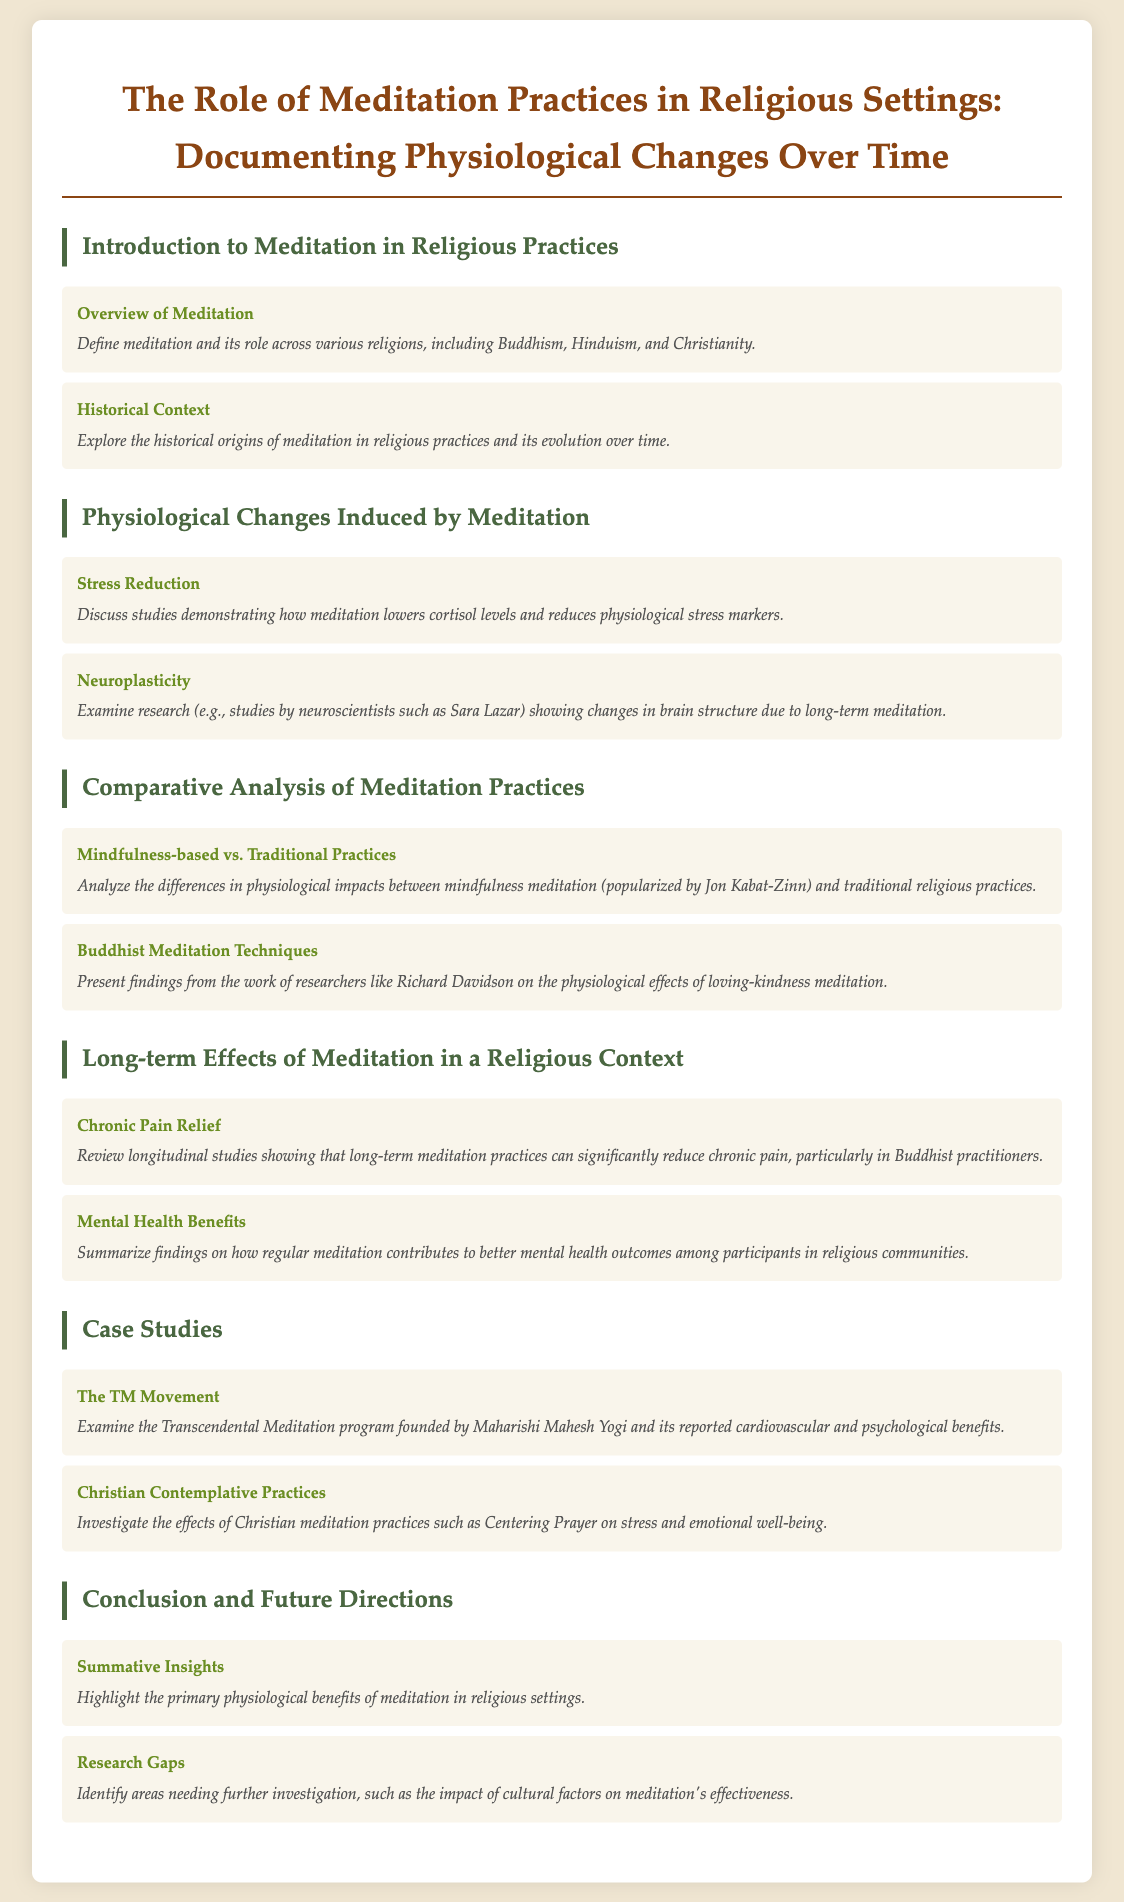What are the two major sections in the document? The document is organized into major sections including "Introduction to Meditation in Religious Practices" and "Physiological Changes Induced by Meditation."
Answer: Introduction to Meditation in Religious Practices and Physiological Changes Induced by Meditation Who founded the TM Movement? The document states that the TM Movement was founded by Maharishi Mahesh Yogi.
Answer: Maharishi Mahesh Yogi What physiological benefit does meditation primarily reduce? The document discusses studies showing that meditation lowers cortisol levels which indicates a reduction in stress.
Answer: Cortisol levels Which meditation practice is compared to traditional practices in the document? The document mentions mindfulness-based meditation as being analyzed in comparison to traditional practices.
Answer: Mindfulness-based What historical aspect does the document explore about meditation? The document explores the historical origins of meditation in religious practices and their evolution over time.
Answer: Historical origins How many case studies are included in the document? The document includes two case studies, "The TM Movement" and "Christian Contemplative Practices."
Answer: Two What findings are summarized about mental health? The document summarizes findings on how regular meditation contributes to better mental health outcomes in religious communities.
Answer: Better mental health outcomes Which researcher is mentioned in relation to neuroplasticity due to meditation? The document references the work of neuroscientist Sara Lazar regarding neuroplasticity from long-term meditation.
Answer: Sara Lazar What is identified as a need for further investigation in the document? The document identifies the impact of cultural factors on meditation's effectiveness as an area needing further research.
Answer: Impact of cultural factors 